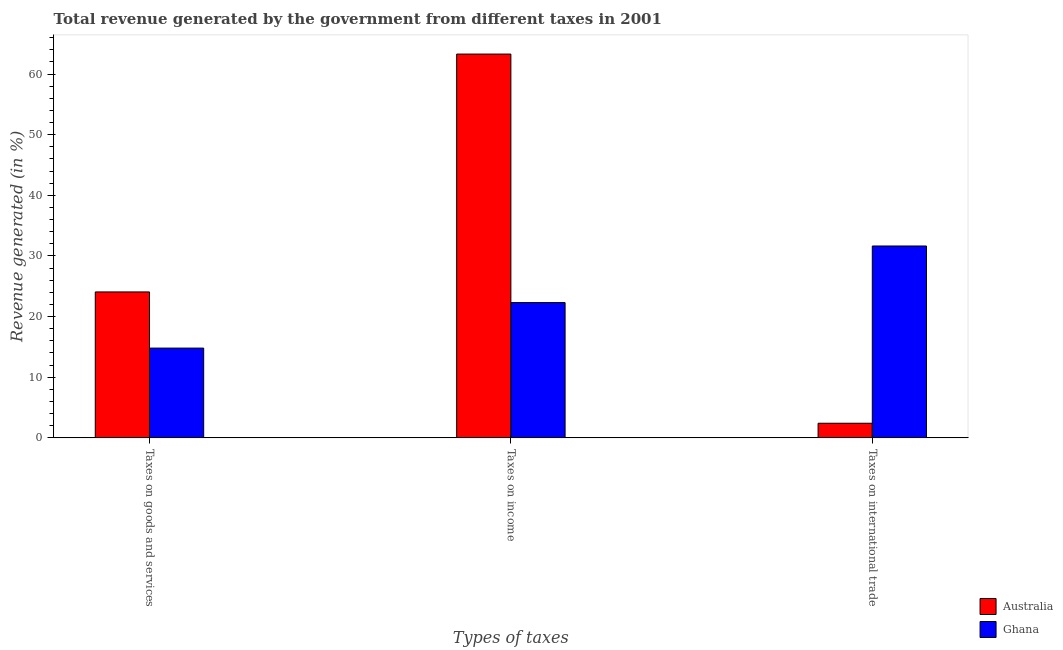How many different coloured bars are there?
Provide a short and direct response. 2. How many groups of bars are there?
Your answer should be compact. 3. Are the number of bars per tick equal to the number of legend labels?
Make the answer very short. Yes. Are the number of bars on each tick of the X-axis equal?
Your answer should be very brief. Yes. How many bars are there on the 2nd tick from the right?
Provide a succinct answer. 2. What is the label of the 1st group of bars from the left?
Your answer should be compact. Taxes on goods and services. What is the percentage of revenue generated by tax on international trade in Ghana?
Give a very brief answer. 31.64. Across all countries, what is the maximum percentage of revenue generated by taxes on income?
Ensure brevity in your answer.  63.29. Across all countries, what is the minimum percentage of revenue generated by taxes on goods and services?
Keep it short and to the point. 14.8. In which country was the percentage of revenue generated by tax on international trade maximum?
Ensure brevity in your answer.  Ghana. What is the total percentage of revenue generated by taxes on goods and services in the graph?
Your answer should be compact. 38.87. What is the difference between the percentage of revenue generated by tax on international trade in Australia and that in Ghana?
Provide a succinct answer. -29.23. What is the difference between the percentage of revenue generated by taxes on income in Australia and the percentage of revenue generated by tax on international trade in Ghana?
Ensure brevity in your answer.  31.65. What is the average percentage of revenue generated by taxes on goods and services per country?
Offer a terse response. 19.43. What is the difference between the percentage of revenue generated by tax on international trade and percentage of revenue generated by taxes on income in Ghana?
Provide a succinct answer. 9.33. What is the ratio of the percentage of revenue generated by taxes on goods and services in Ghana to that in Australia?
Keep it short and to the point. 0.62. Is the difference between the percentage of revenue generated by taxes on income in Ghana and Australia greater than the difference between the percentage of revenue generated by taxes on goods and services in Ghana and Australia?
Your response must be concise. No. What is the difference between the highest and the second highest percentage of revenue generated by taxes on income?
Provide a succinct answer. 40.99. What is the difference between the highest and the lowest percentage of revenue generated by taxes on income?
Offer a very short reply. 40.99. In how many countries, is the percentage of revenue generated by taxes on income greater than the average percentage of revenue generated by taxes on income taken over all countries?
Keep it short and to the point. 1. Is the sum of the percentage of revenue generated by taxes on income in Australia and Ghana greater than the maximum percentage of revenue generated by taxes on goods and services across all countries?
Provide a short and direct response. Yes. What does the 1st bar from the left in Taxes on international trade represents?
Your answer should be compact. Australia. Is it the case that in every country, the sum of the percentage of revenue generated by taxes on goods and services and percentage of revenue generated by taxes on income is greater than the percentage of revenue generated by tax on international trade?
Offer a very short reply. Yes. Are all the bars in the graph horizontal?
Provide a succinct answer. No. Are the values on the major ticks of Y-axis written in scientific E-notation?
Provide a short and direct response. No. Where does the legend appear in the graph?
Offer a very short reply. Bottom right. How many legend labels are there?
Provide a short and direct response. 2. What is the title of the graph?
Your answer should be very brief. Total revenue generated by the government from different taxes in 2001. Does "Ecuador" appear as one of the legend labels in the graph?
Your answer should be very brief. No. What is the label or title of the X-axis?
Offer a very short reply. Types of taxes. What is the label or title of the Y-axis?
Offer a terse response. Revenue generated (in %). What is the Revenue generated (in %) in Australia in Taxes on goods and services?
Your response must be concise. 24.07. What is the Revenue generated (in %) of Ghana in Taxes on goods and services?
Offer a terse response. 14.8. What is the Revenue generated (in %) of Australia in Taxes on income?
Give a very brief answer. 63.29. What is the Revenue generated (in %) of Ghana in Taxes on income?
Your response must be concise. 22.31. What is the Revenue generated (in %) of Australia in Taxes on international trade?
Offer a very short reply. 2.41. What is the Revenue generated (in %) of Ghana in Taxes on international trade?
Your response must be concise. 31.64. Across all Types of taxes, what is the maximum Revenue generated (in %) in Australia?
Make the answer very short. 63.29. Across all Types of taxes, what is the maximum Revenue generated (in %) in Ghana?
Give a very brief answer. 31.64. Across all Types of taxes, what is the minimum Revenue generated (in %) of Australia?
Keep it short and to the point. 2.41. Across all Types of taxes, what is the minimum Revenue generated (in %) of Ghana?
Your answer should be compact. 14.8. What is the total Revenue generated (in %) in Australia in the graph?
Keep it short and to the point. 89.77. What is the total Revenue generated (in %) of Ghana in the graph?
Your answer should be very brief. 68.75. What is the difference between the Revenue generated (in %) of Australia in Taxes on goods and services and that in Taxes on income?
Give a very brief answer. -39.23. What is the difference between the Revenue generated (in %) in Ghana in Taxes on goods and services and that in Taxes on income?
Keep it short and to the point. -7.5. What is the difference between the Revenue generated (in %) in Australia in Taxes on goods and services and that in Taxes on international trade?
Provide a succinct answer. 21.65. What is the difference between the Revenue generated (in %) of Ghana in Taxes on goods and services and that in Taxes on international trade?
Offer a very short reply. -16.84. What is the difference between the Revenue generated (in %) of Australia in Taxes on income and that in Taxes on international trade?
Your response must be concise. 60.88. What is the difference between the Revenue generated (in %) in Ghana in Taxes on income and that in Taxes on international trade?
Provide a short and direct response. -9.33. What is the difference between the Revenue generated (in %) in Australia in Taxes on goods and services and the Revenue generated (in %) in Ghana in Taxes on income?
Provide a succinct answer. 1.76. What is the difference between the Revenue generated (in %) of Australia in Taxes on goods and services and the Revenue generated (in %) of Ghana in Taxes on international trade?
Make the answer very short. -7.58. What is the difference between the Revenue generated (in %) in Australia in Taxes on income and the Revenue generated (in %) in Ghana in Taxes on international trade?
Your response must be concise. 31.65. What is the average Revenue generated (in %) in Australia per Types of taxes?
Offer a terse response. 29.92. What is the average Revenue generated (in %) of Ghana per Types of taxes?
Your answer should be very brief. 22.92. What is the difference between the Revenue generated (in %) in Australia and Revenue generated (in %) in Ghana in Taxes on goods and services?
Offer a very short reply. 9.26. What is the difference between the Revenue generated (in %) of Australia and Revenue generated (in %) of Ghana in Taxes on income?
Provide a short and direct response. 40.99. What is the difference between the Revenue generated (in %) in Australia and Revenue generated (in %) in Ghana in Taxes on international trade?
Keep it short and to the point. -29.23. What is the ratio of the Revenue generated (in %) in Australia in Taxes on goods and services to that in Taxes on income?
Your answer should be very brief. 0.38. What is the ratio of the Revenue generated (in %) in Ghana in Taxes on goods and services to that in Taxes on income?
Your response must be concise. 0.66. What is the ratio of the Revenue generated (in %) in Australia in Taxes on goods and services to that in Taxes on international trade?
Your answer should be compact. 9.98. What is the ratio of the Revenue generated (in %) of Ghana in Taxes on goods and services to that in Taxes on international trade?
Offer a terse response. 0.47. What is the ratio of the Revenue generated (in %) of Australia in Taxes on income to that in Taxes on international trade?
Your answer should be compact. 26.24. What is the ratio of the Revenue generated (in %) in Ghana in Taxes on income to that in Taxes on international trade?
Keep it short and to the point. 0.7. What is the difference between the highest and the second highest Revenue generated (in %) of Australia?
Your answer should be compact. 39.23. What is the difference between the highest and the second highest Revenue generated (in %) in Ghana?
Your answer should be very brief. 9.33. What is the difference between the highest and the lowest Revenue generated (in %) of Australia?
Give a very brief answer. 60.88. What is the difference between the highest and the lowest Revenue generated (in %) in Ghana?
Offer a terse response. 16.84. 